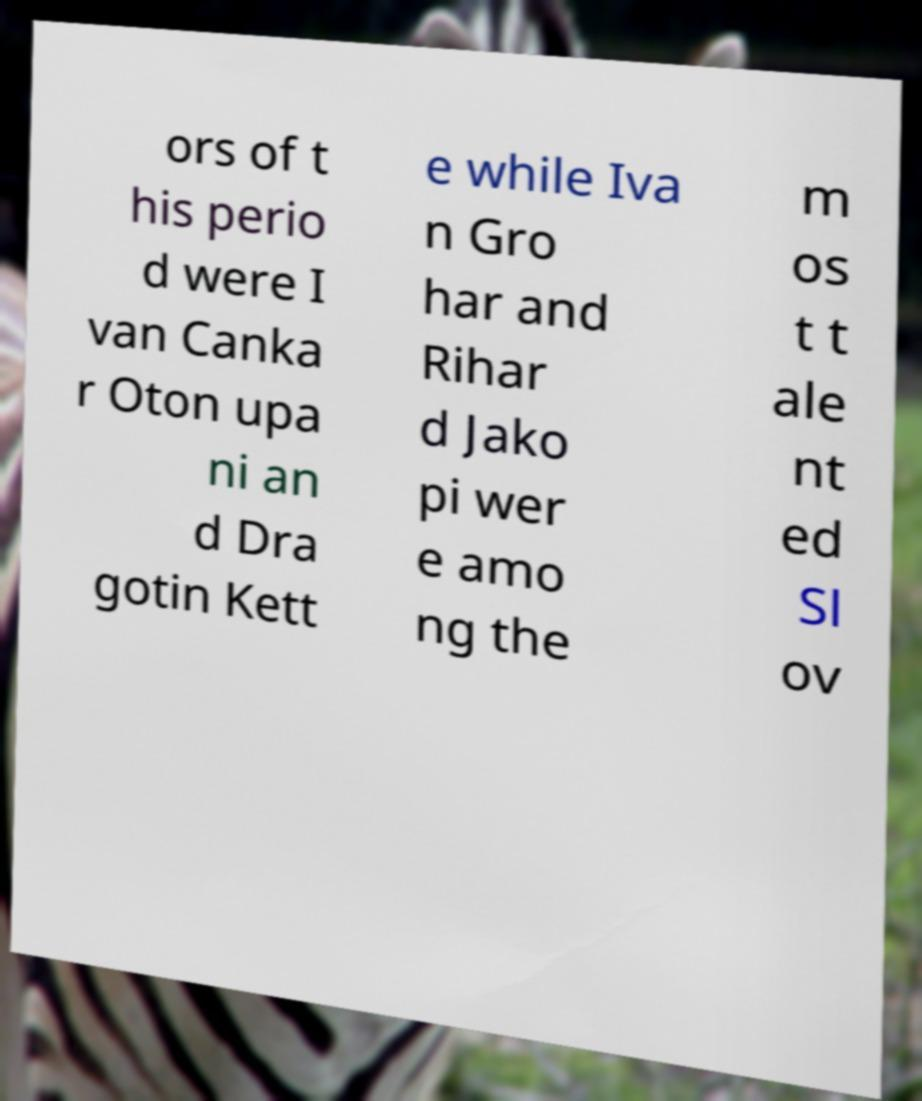For documentation purposes, I need the text within this image transcribed. Could you provide that? ors of t his perio d were I van Canka r Oton upa ni an d Dra gotin Kett e while Iva n Gro har and Rihar d Jako pi wer e amo ng the m os t t ale nt ed Sl ov 